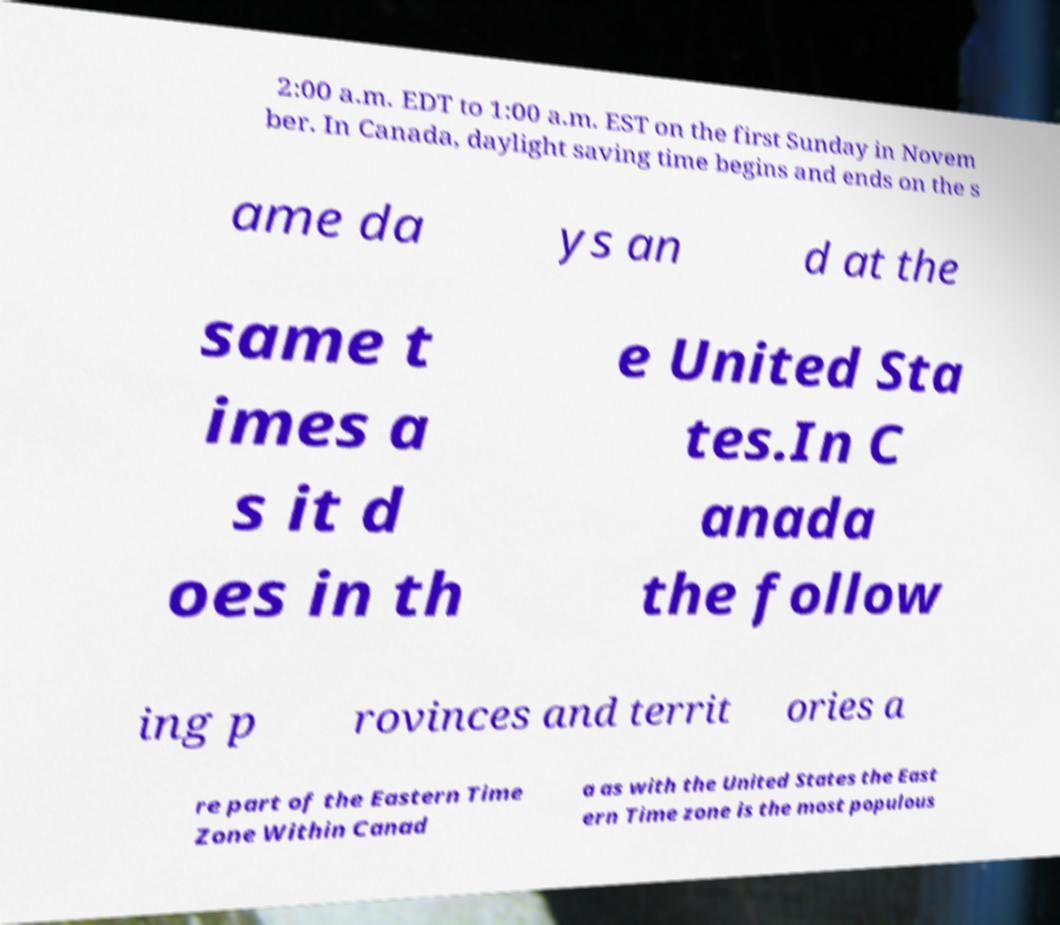For documentation purposes, I need the text within this image transcribed. Could you provide that? 2:00 a.m. EDT to 1:00 a.m. EST on the first Sunday in Novem ber. In Canada, daylight saving time begins and ends on the s ame da ys an d at the same t imes a s it d oes in th e United Sta tes.In C anada the follow ing p rovinces and territ ories a re part of the Eastern Time Zone Within Canad a as with the United States the East ern Time zone is the most populous 